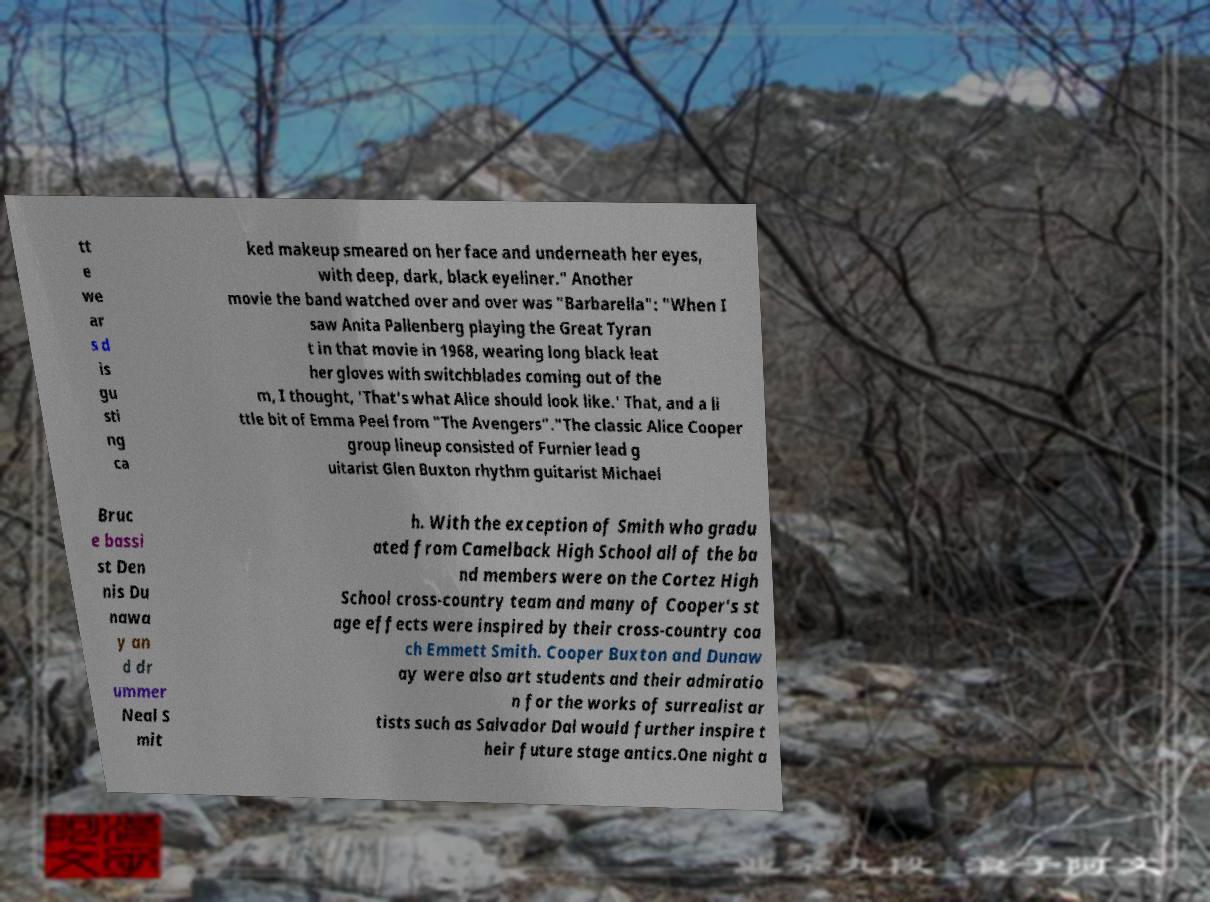I need the written content from this picture converted into text. Can you do that? tt e we ar s d is gu sti ng ca ked makeup smeared on her face and underneath her eyes, with deep, dark, black eyeliner." Another movie the band watched over and over was "Barbarella": "When I saw Anita Pallenberg playing the Great Tyran t in that movie in 1968, wearing long black leat her gloves with switchblades coming out of the m, I thought, 'That's what Alice should look like.' That, and a li ttle bit of Emma Peel from "The Avengers"."The classic Alice Cooper group lineup consisted of Furnier lead g uitarist Glen Buxton rhythm guitarist Michael Bruc e bassi st Den nis Du nawa y an d dr ummer Neal S mit h. With the exception of Smith who gradu ated from Camelback High School all of the ba nd members were on the Cortez High School cross-country team and many of Cooper's st age effects were inspired by their cross-country coa ch Emmett Smith. Cooper Buxton and Dunaw ay were also art students and their admiratio n for the works of surrealist ar tists such as Salvador Dal would further inspire t heir future stage antics.One night a 